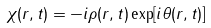Convert formula to latex. <formula><loc_0><loc_0><loc_500><loc_500>\chi ( r , t ) = - i \rho ( r , t ) \exp [ i \theta ( r , t ) ]</formula> 